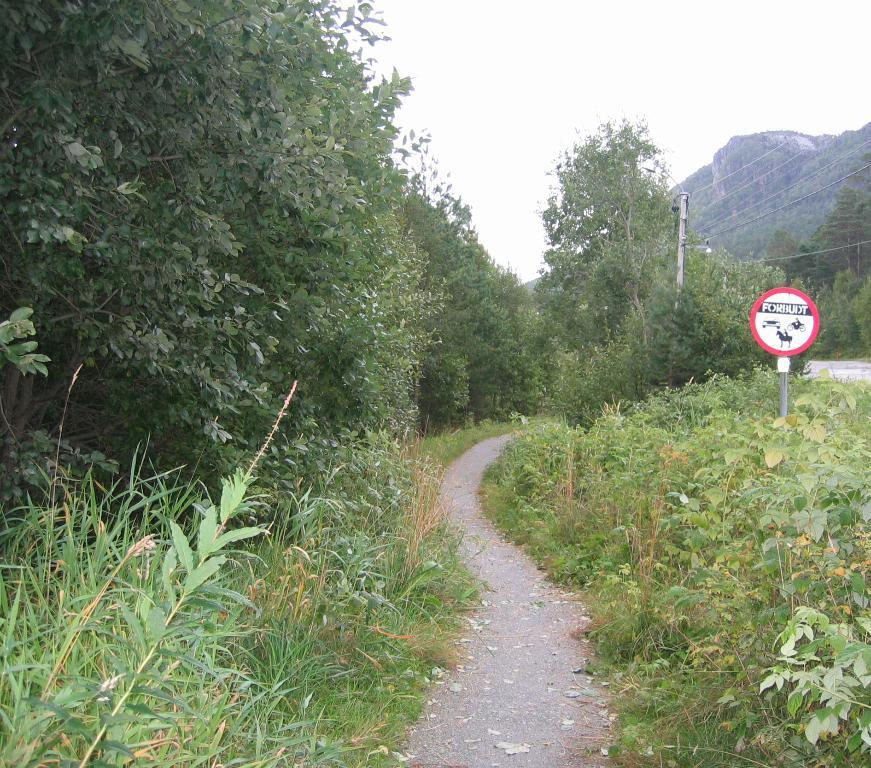What is the main object in the image? There is a signboard in the image. What else can be seen in the image besides the signboard? There are poles, plants, a road, trees, and a hill visible in the image. What is the natural environment like in the image? The image features plants, trees, and a hill, indicating a natural setting. What is visible in the sky in the image? The sky is visible in the image. What type of pancake is being served at the impulse stop in the image? There is no impulse stop or pancake present in the image. 